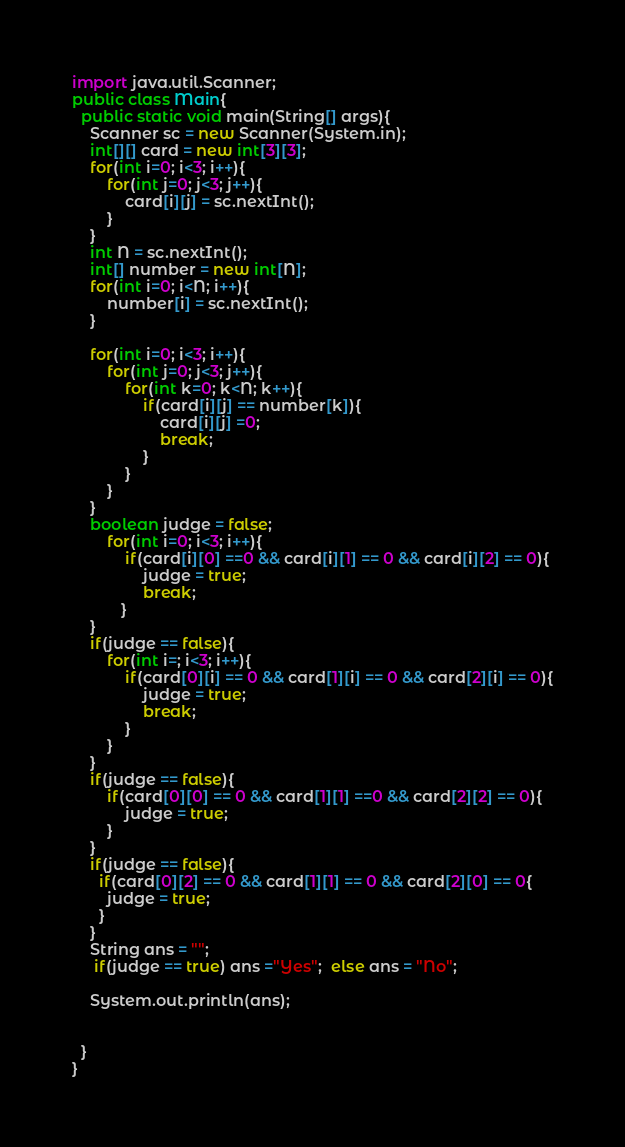<code> <loc_0><loc_0><loc_500><loc_500><_Java_>import java.util.Scanner;
public class Main{
  public static void main(String[] args){
	Scanner sc = new Scanner(System.in);
    int[][] card = new int[3][3];
    for(int i=0; i<3; i++){
    	for(int j=0; j<3; j++){
        	card[i][j] = sc.nextInt();
        }
    }
    int N = sc.nextInt();
    int[] number = new int[N];
    for(int i=0; i<N; i++){
    	number[i] = sc.nextInt();
    }
    
    for(int i=0; i<3; i++){
		for(int j=0; j<3; j++){
        	for(int k=0; k<N; k++){
            	if(card[i][j] == number[k]){
                	card[i][j] =0;
                    break;
                }
            }
        }    
    }
    boolean judge = false;
    	for(int i=0; i<3; i++){
    		if(card[i][0] ==0 && card[i][1] == 0 && card[i][2] == 0){
    			judge = true;
        		break;
           }
    }
    if(judge == false){
    	for(int i=; i<3; i++){
            if(card[0][i] == 0 && card[1][i] == 0 && card[2][i] == 0){
              	judge = true;
                break;
            }
    	}   
    }
    if(judge == false){
    	if(card[0][0] == 0 && card[1][1] ==0 && card[2][2] == 0){
        	judge = true;
        }
    }
    if(judge == false){
      if(card[0][2] == 0 && card[1][1] == 0 && card[2][0] == 0{
        judge = true;
      }
    }
    String ans = "";
     if(judge == true) ans ="Yes";  else ans = "No";
     
    System.out.println(ans);
    
    
  }
}</code> 